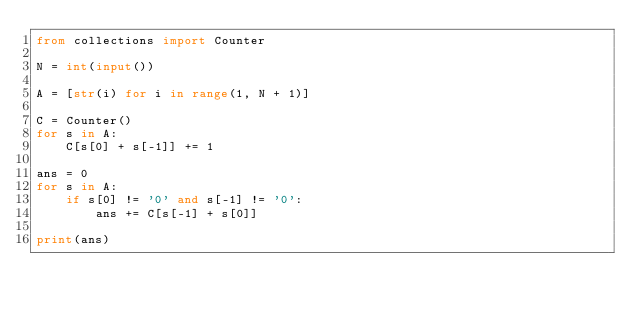<code> <loc_0><loc_0><loc_500><loc_500><_Python_>from collections import Counter

N = int(input())

A = [str(i) for i in range(1, N + 1)]

C = Counter()
for s in A:
    C[s[0] + s[-1]] += 1

ans = 0
for s in A:
    if s[0] != '0' and s[-1] != '0':
        ans += C[s[-1] + s[0]]

print(ans)
</code> 